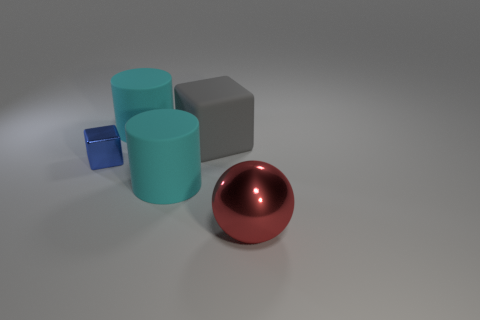Add 3 big blue balls. How many objects exist? 8 Subtract all cylinders. How many objects are left? 3 Subtract 0 cyan spheres. How many objects are left? 5 Subtract all big blue rubber cylinders. Subtract all large red metal balls. How many objects are left? 4 Add 1 cyan rubber objects. How many cyan rubber objects are left? 3 Add 2 matte things. How many matte things exist? 5 